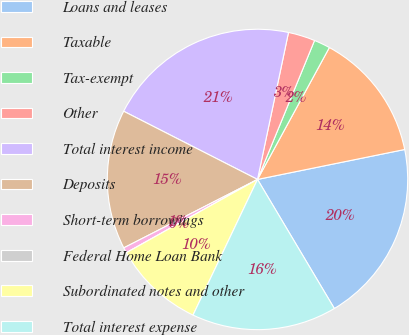<chart> <loc_0><loc_0><loc_500><loc_500><pie_chart><fcel>Loans and leases<fcel>Taxable<fcel>Tax-exempt<fcel>Other<fcel>Total interest income<fcel>Deposits<fcel>Short-term borrowings<fcel>Federal Home Loan Bank<fcel>Subordinated notes and other<fcel>Total interest expense<nl><fcel>19.65%<fcel>13.87%<fcel>1.74%<fcel>2.89%<fcel>20.81%<fcel>15.03%<fcel>0.58%<fcel>0.0%<fcel>9.83%<fcel>15.61%<nl></chart> 